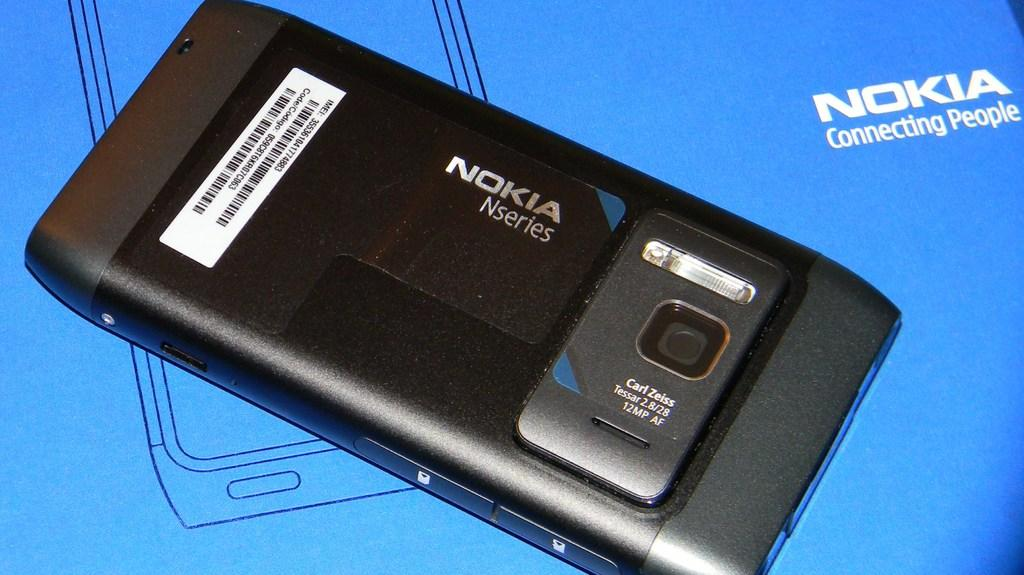Provide a one-sentence caption for the provided image. Nokia Nseries phone and box that connects people. 